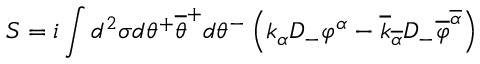Convert formula to latex. <formula><loc_0><loc_0><loc_500><loc_500>S = i \int d ^ { 2 } \sigma d \theta ^ { + } \overline { \theta } ^ { + } d \theta ^ { - } \left ( k _ { \alpha } D _ { - } \varphi ^ { \alpha } - \overline { k } _ { \overline { \alpha } } D _ { - } \overline { \varphi } ^ { \overline { \alpha } } \right )</formula> 